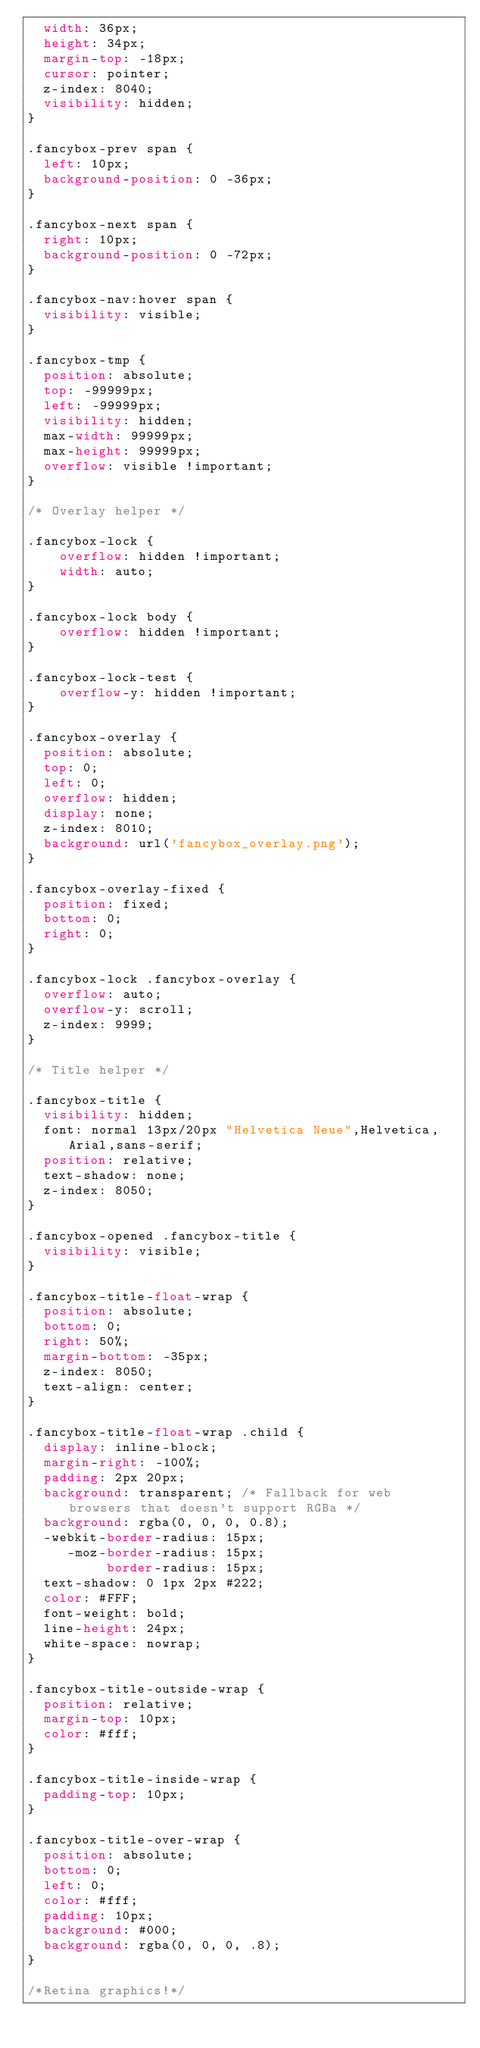Convert code to text. <code><loc_0><loc_0><loc_500><loc_500><_CSS_>	width: 36px;
	height: 34px;
	margin-top: -18px;
	cursor: pointer;
	z-index: 8040;
	visibility: hidden;
}

.fancybox-prev span {
	left: 10px;
	background-position: 0 -36px;
}

.fancybox-next span {
	right: 10px;
	background-position: 0 -72px;
}

.fancybox-nav:hover span {
	visibility: visible;
}

.fancybox-tmp {
	position: absolute;
	top: -99999px;
	left: -99999px;
	visibility: hidden;
	max-width: 99999px;
	max-height: 99999px;
	overflow: visible !important;
}

/* Overlay helper */

.fancybox-lock {
    overflow: hidden !important;
    width: auto;
}

.fancybox-lock body {
    overflow: hidden !important;
}

.fancybox-lock-test {
    overflow-y: hidden !important;
}

.fancybox-overlay {
	position: absolute;
	top: 0;
	left: 0;
	overflow: hidden;
	display: none;
	z-index: 8010;
	background: url('fancybox_overlay.png');
}

.fancybox-overlay-fixed {
	position: fixed;
	bottom: 0;
	right: 0;
}

.fancybox-lock .fancybox-overlay {
	overflow: auto;
	overflow-y: scroll;
	z-index: 9999;
}

/* Title helper */

.fancybox-title {
	visibility: hidden;
	font: normal 13px/20px "Helvetica Neue",Helvetica,Arial,sans-serif;
	position: relative;
	text-shadow: none;
	z-index: 8050;
}

.fancybox-opened .fancybox-title {
	visibility: visible;
}

.fancybox-title-float-wrap {
	position: absolute;
	bottom: 0;
	right: 50%;
	margin-bottom: -35px;
	z-index: 8050;
	text-align: center;
}

.fancybox-title-float-wrap .child {
	display: inline-block;
	margin-right: -100%;
	padding: 2px 20px;
	background: transparent; /* Fallback for web browsers that doesn't support RGBa */
	background: rgba(0, 0, 0, 0.8);
	-webkit-border-radius: 15px;
	   -moz-border-radius: 15px;
	        border-radius: 15px;
	text-shadow: 0 1px 2px #222;
	color: #FFF;
	font-weight: bold;
	line-height: 24px;
	white-space: nowrap;
}

.fancybox-title-outside-wrap {
	position: relative;
	margin-top: 10px;
	color: #fff;
}

.fancybox-title-inside-wrap {
	padding-top: 10px;
}

.fancybox-title-over-wrap {
	position: absolute;
	bottom: 0;
	left: 0;
	color: #fff;
	padding: 10px;
	background: #000;
	background: rgba(0, 0, 0, .8);
}

/*Retina graphics!*/</code> 